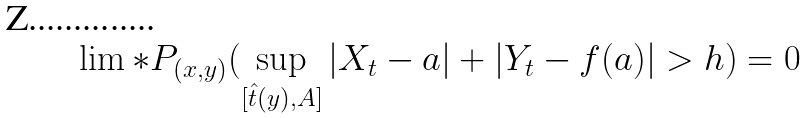<formula> <loc_0><loc_0><loc_500><loc_500>\lim * { P } _ { ( x , y ) } ( \sup _ { [ { \hat { t } } ( y ) , A ] } | X _ { t } - a | + | Y _ { t } - f ( a ) | > h ) = 0</formula> 